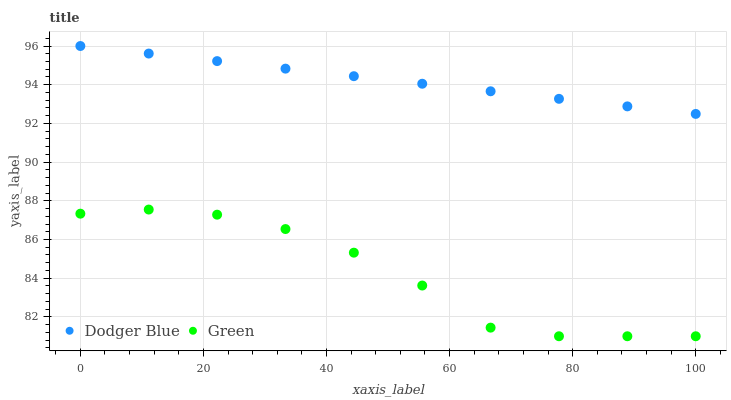Does Green have the minimum area under the curve?
Answer yes or no. Yes. Does Dodger Blue have the maximum area under the curve?
Answer yes or no. Yes. Does Dodger Blue have the minimum area under the curve?
Answer yes or no. No. Is Dodger Blue the smoothest?
Answer yes or no. Yes. Is Green the roughest?
Answer yes or no. Yes. Is Dodger Blue the roughest?
Answer yes or no. No. Does Green have the lowest value?
Answer yes or no. Yes. Does Dodger Blue have the lowest value?
Answer yes or no. No. Does Dodger Blue have the highest value?
Answer yes or no. Yes. Is Green less than Dodger Blue?
Answer yes or no. Yes. Is Dodger Blue greater than Green?
Answer yes or no. Yes. Does Green intersect Dodger Blue?
Answer yes or no. No. 